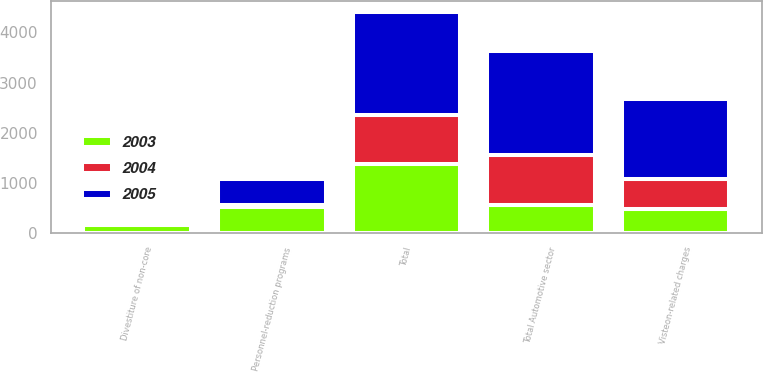<chart> <loc_0><loc_0><loc_500><loc_500><stacked_bar_chart><ecel><fcel>Visteon-related charges<fcel>Personnel-reduction programs<fcel>Divestiture of non-core<fcel>Total Automotive sector<fcel>Total<nl><fcel>2003<fcel>468<fcel>510<fcel>152<fcel>556.5<fcel>1382<nl><fcel>2004<fcel>600<fcel>49<fcel>17<fcel>1005<fcel>960<nl><fcel>2005<fcel>1597<fcel>513<fcel>49<fcel>2061<fcel>2061<nl></chart> 